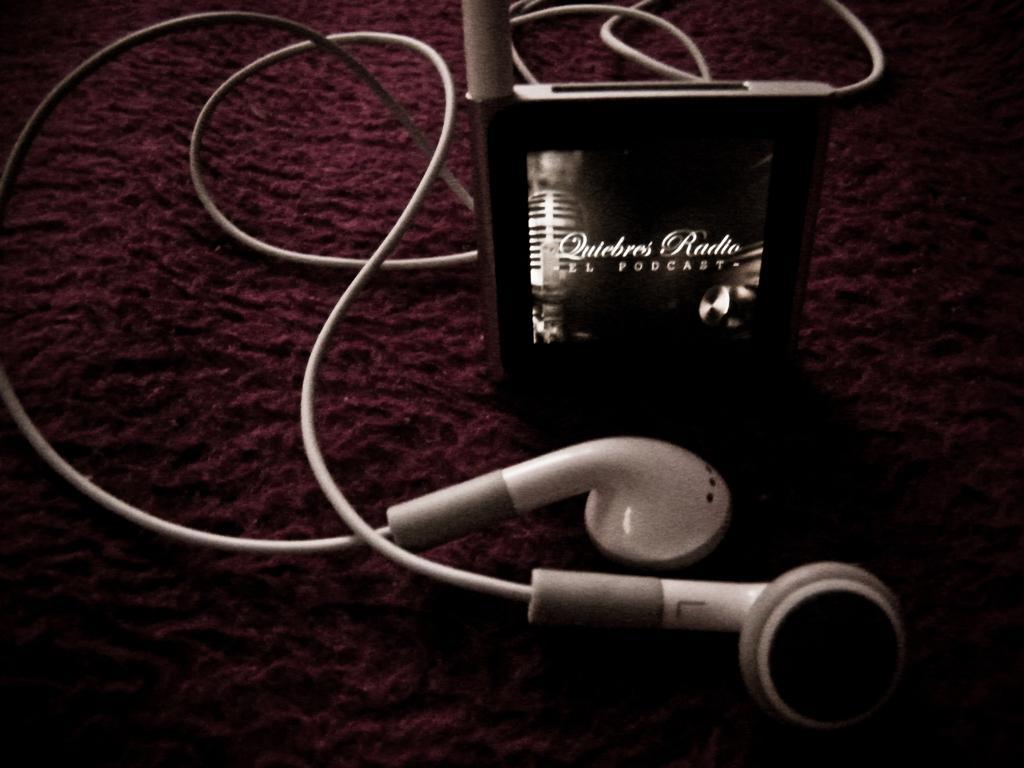Please provide a concise description of this image. In this image, we can see a device with headphones connected to it. We can also see the ground. 